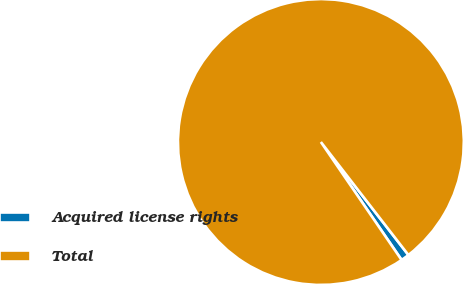Convert chart to OTSL. <chart><loc_0><loc_0><loc_500><loc_500><pie_chart><fcel>Acquired license rights<fcel>Total<nl><fcel>0.94%<fcel>99.06%<nl></chart> 